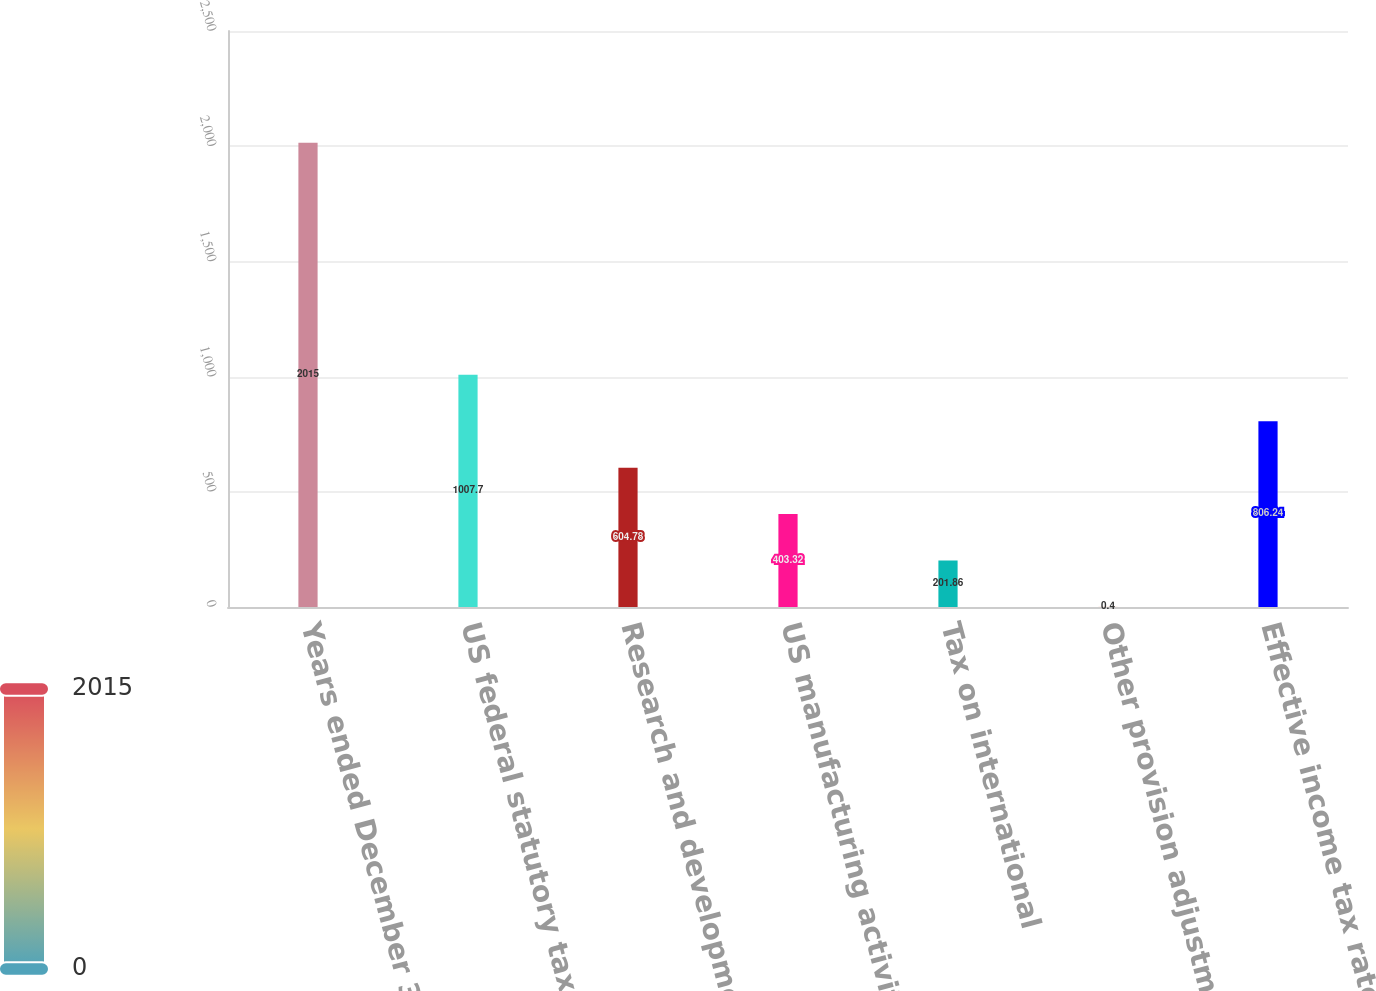Convert chart to OTSL. <chart><loc_0><loc_0><loc_500><loc_500><bar_chart><fcel>Years ended December 31<fcel>US federal statutory tax<fcel>Research and development<fcel>US manufacturing activity tax<fcel>Tax on international<fcel>Other provision adjustments<fcel>Effective income tax rate<nl><fcel>2015<fcel>1007.7<fcel>604.78<fcel>403.32<fcel>201.86<fcel>0.4<fcel>806.24<nl></chart> 